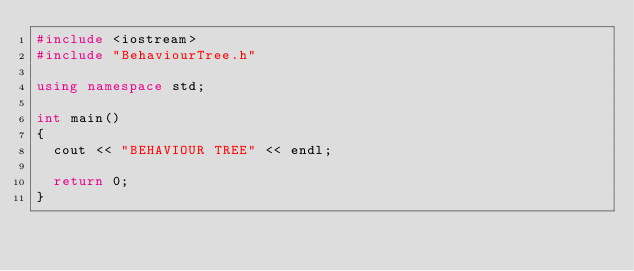Convert code to text. <code><loc_0><loc_0><loc_500><loc_500><_C++_>#include <iostream>
#include "BehaviourTree.h"

using namespace std;

int main()
{
  cout << "BEHAVIOUR TREE" << endl;

  return 0;
}</code> 